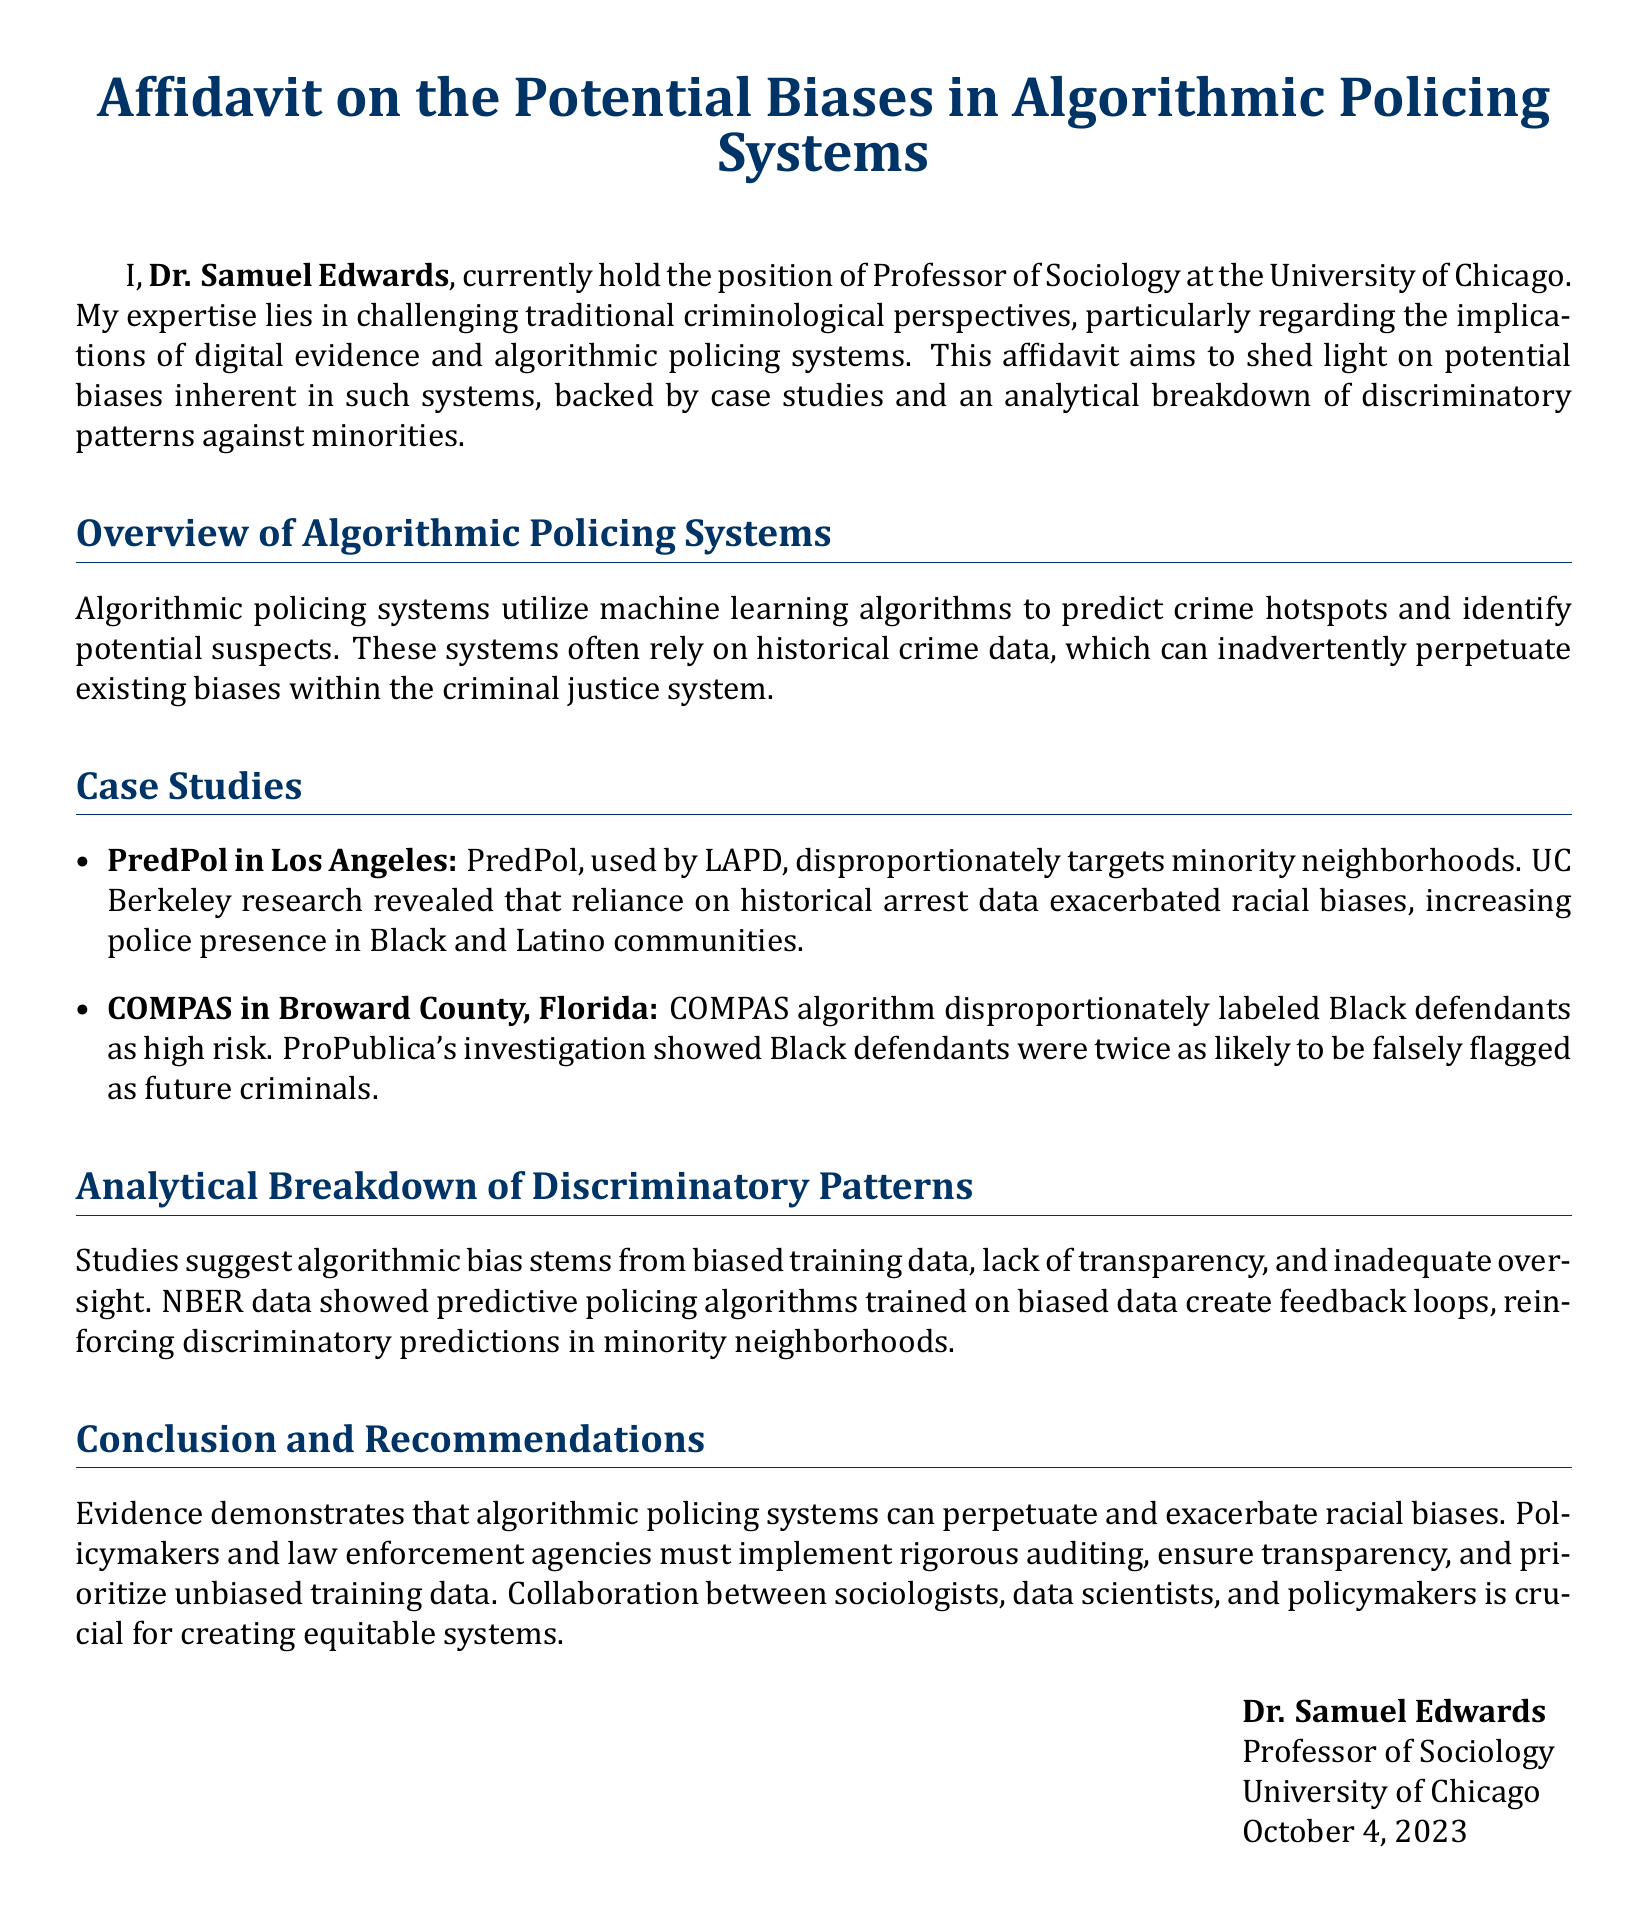What is the title of the affidavit? The title of the affidavit is explicitly mentioned at the beginning of the document, which is "Affidavit on the Potential Biases in Algorithmic Policing Systems."
Answer: Affidavit on the Potential Biases in Algorithmic Policing Systems Who is the affiant? The affiant is the individual who signs the affidavit, which in this case is Dr. Samuel Edwards.
Answer: Dr. Samuel Edwards What position does Dr. Samuel Edwards hold? Dr. Samuel Edwards' position is stated as Professor of Sociology at the University of Chicago.
Answer: Professor of Sociology What algorithm is used by the LAPD? The document specifies the algorithm used by the LAPD as PredPol.
Answer: PredPol Which county is the COMPAS algorithm associated with? The document clearly states that the COMPAS algorithm is associated with Broward County, Florida.
Answer: Broward County, Florida What major factor contributes to algorithmic bias according to the document? The document mentions biased training data as a major factor contributing to algorithmic bias.
Answer: Biased training data What does the acronym NBER stand for? The acronym NBER, mentioned in the context of data, stands for the National Bureau of Economic Research.
Answer: National Bureau of Economic Research What is the date of the affidavit signing? The affidavit was signed on October 4, 2023.
Answer: October 4, 2023 What is one of the recommendations made in the affidavit? The affidavit recommends implementing rigorous auditing as one of the measures to address biases in algorithmic policing systems.
Answer: Implementing rigorous auditing 